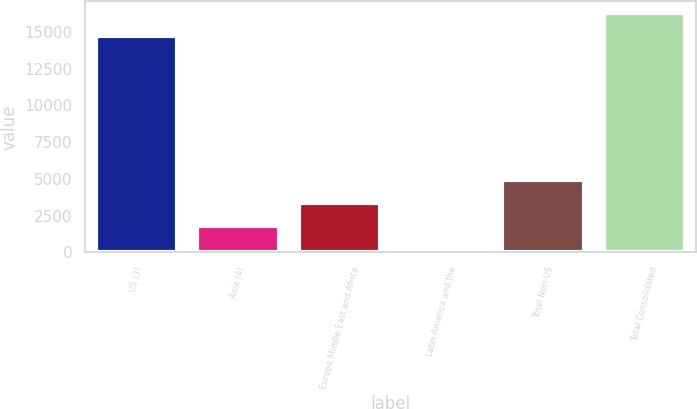Convert chart to OTSL. <chart><loc_0><loc_0><loc_500><loc_500><bar_chart><fcel>US (3)<fcel>Asia (4)<fcel>Europe Middle East and Africa<fcel>Latin America and the<fcel>Total Non-US<fcel>Total Consolidated<nl><fcel>14689<fcel>1792.2<fcel>3358.4<fcel>226<fcel>4924.6<fcel>16255.2<nl></chart> 